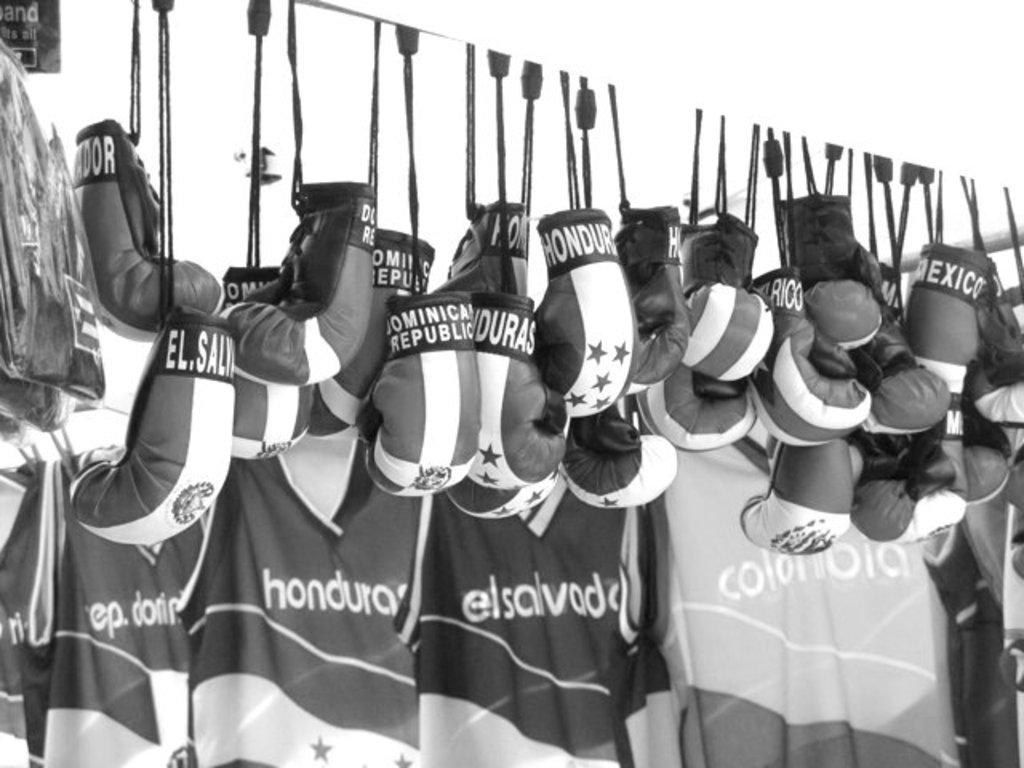<image>
Offer a succinct explanation of the picture presented. clothing and boxing punching gloves for the honduras team members 